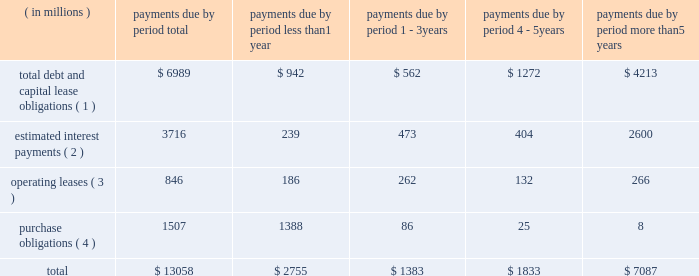Bhge 2018 form 10-k | 41 estimate would equal up to 5% ( 5 % ) of annual revenue .
The expenditures are expected to be used primarily for normal , recurring items necessary to support our business .
We also anticipate making income tax payments in the range of $ 425 million to $ 475 million in 2019 .
Contractual obligations in the table below , we set forth our contractual obligations as of december 31 , 2018 .
Certain amounts included in this table are based on our estimates and assumptions about these obligations , including their duration , anticipated actions by third parties and other factors .
The contractual obligations we will actually pay in future periods may vary from those reflected in the table because the estimates and assumptions are subjective. .
( 1 ) amounts represent the expected cash payments for the principal amounts related to our debt , including capital lease obligations .
Amounts for debt do not include any deferred issuance costs or unamortized discounts or premiums including step up in the value of the debt on the acquisition of baker hughes .
Expected cash payments for interest are excluded from these amounts .
Total debt and capital lease obligations includes $ 896 million payable to ge and its affiliates .
As there is no fixed payment schedule on the amount payable to ge and its affiliates we have classified it as payable in less than one year .
( 2 ) amounts represent the expected cash payments for interest on our long-term debt and capital lease obligations .
( 3 ) amounts represent the future minimum payments under noncancelable operating leases with initial or remaining terms of one year or more .
We enter into operating leases , some of which include renewal options , however , we have excluded renewal options from the table above unless it is anticipated that we will exercise such renewals .
( 4 ) purchase obligations include expenditures for capital assets for 2019 as well as agreements to purchase goods or services that are enforceable and legally binding and that specify all significant terms , including : fixed or minimum quantities to be purchased ; fixed , minimum or variable price provisions ; and the approximate timing of the transaction .
Due to the uncertainty with respect to the timing of potential future cash outflows associated with our uncertain tax positions , we are unable to make reasonable estimates of the period of cash settlement , if any , to the respective taxing authorities .
Therefore , $ 597 million in uncertain tax positions , including interest and penalties , have been excluded from the contractual obligations table above .
See "note 12 .
Income taxes" of the notes to consolidated and combined financial statements in item 8 herein for further information .
We have certain defined benefit pension and other post-retirement benefit plans covering certain of our u.s .
And international employees .
During 2018 , we made contributions and paid direct benefits of approximately $ 72 million in connection with those plans , and we anticipate funding approximately $ 41 million during 2019 .
Amounts for pension funding obligations are based on assumptions that are subject to change , therefore , we are currently not able to reasonably estimate our contribution figures after 2019 .
See "note 11 .
Employee benefit plans" of the notes to consolidated and combined financial statements in item 8 herein for further information .
Off-balance sheet arrangements in the normal course of business with customers , vendors and others , we have entered into off-balance sheet arrangements , such as surety bonds for performance , letters of credit and other bank issued guarantees , which totaled approximately $ 3.6 billion at december 31 , 2018 .
It is not practicable to estimate the fair value of these financial instruments .
None of the off-balance sheet arrangements either has , or is likely to have , a material effect on our consolidated and combined financial statements. .
What are the total debt and capital lease obligations as a percentage of the total payments due? 
Computations: (6989 / 13058)
Answer: 0.53523. 